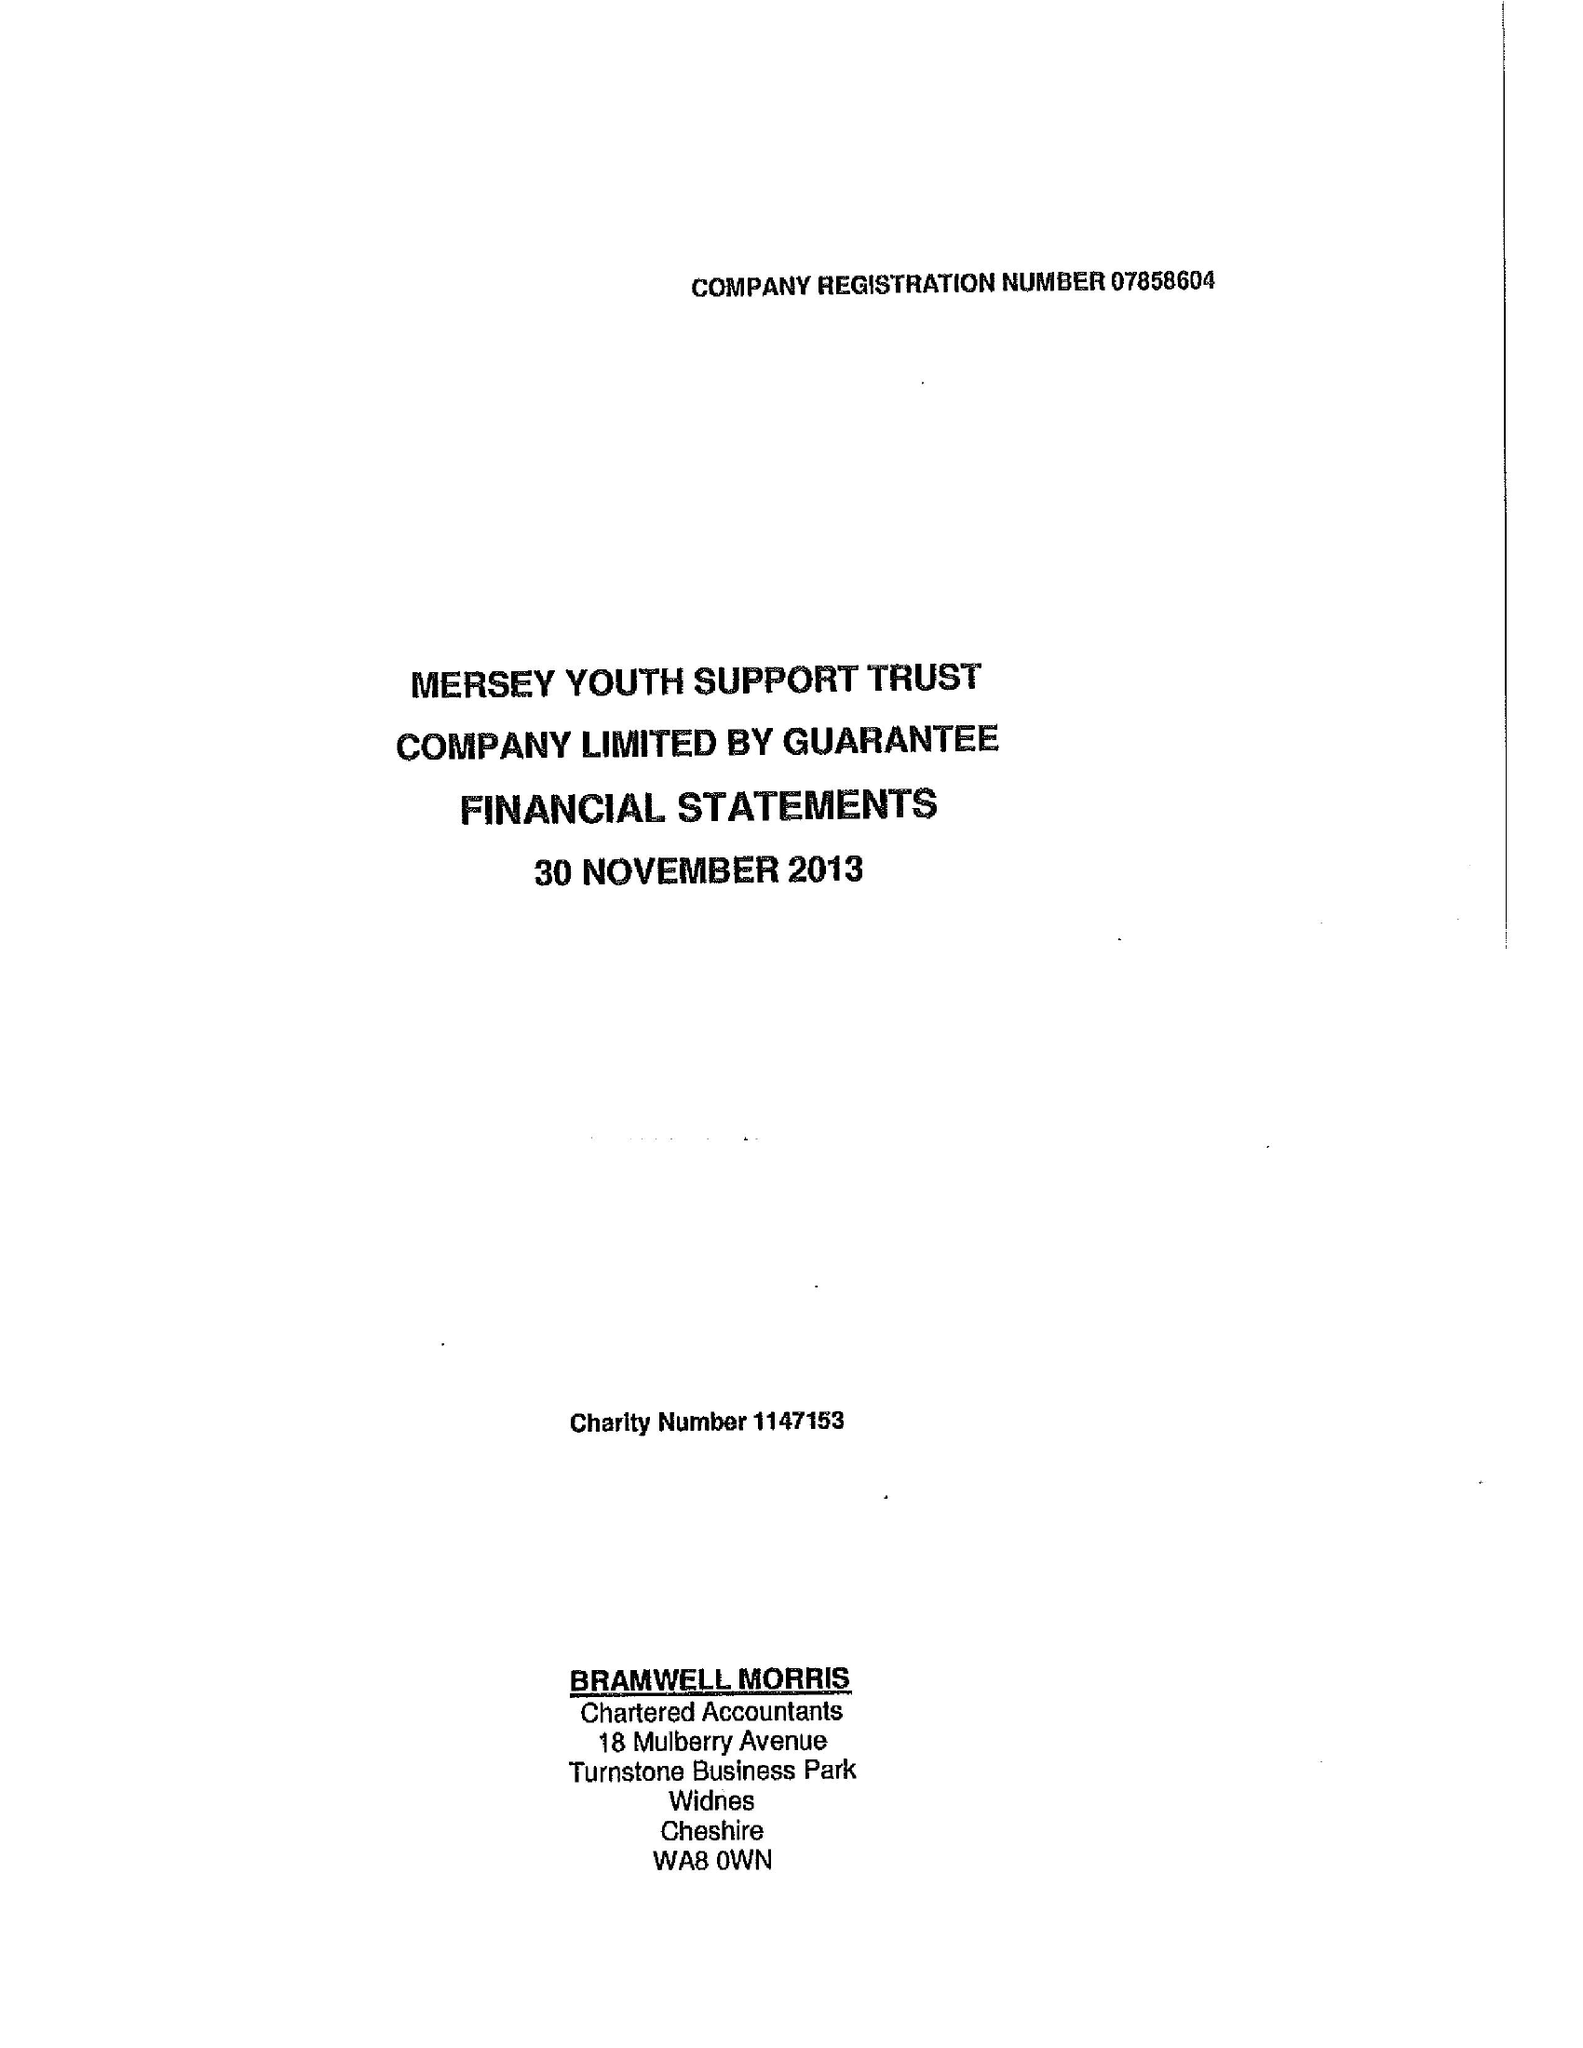What is the value for the charity_number?
Answer the question using a single word or phrase. 1147153 